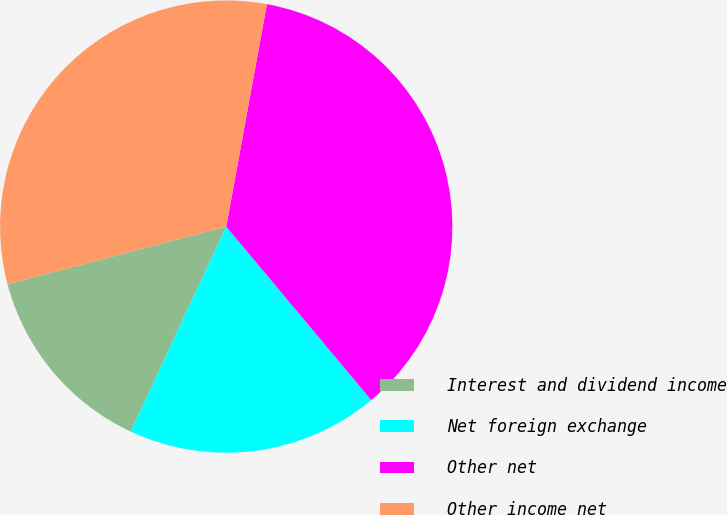Convert chart to OTSL. <chart><loc_0><loc_0><loc_500><loc_500><pie_chart><fcel>Interest and dividend income<fcel>Net foreign exchange<fcel>Other net<fcel>Other income net<nl><fcel>13.96%<fcel>18.02%<fcel>36.04%<fcel>31.98%<nl></chart> 